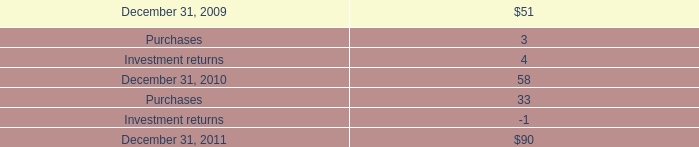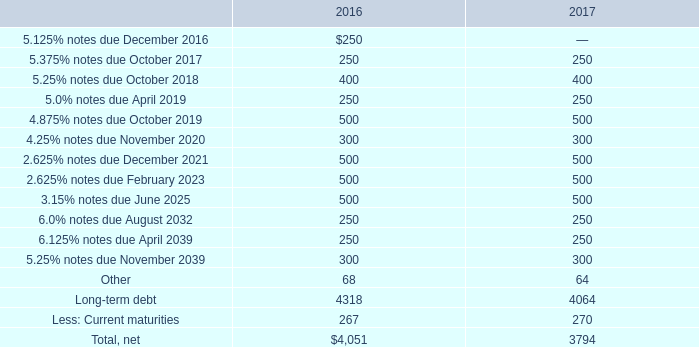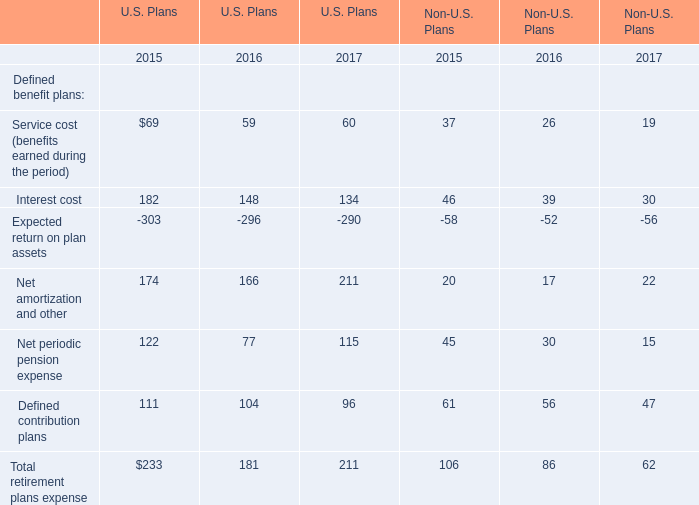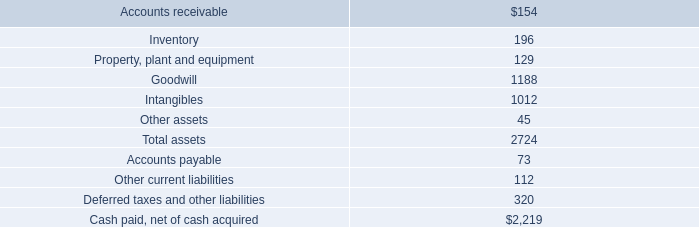If Net amortization and other in U.S. Plans develops with the same increasing rate in 2017, what will it reach in 2018? 
Computations: ((1 + ((211 - 166) / 166)) * 211)
Answer: 268.1988. 